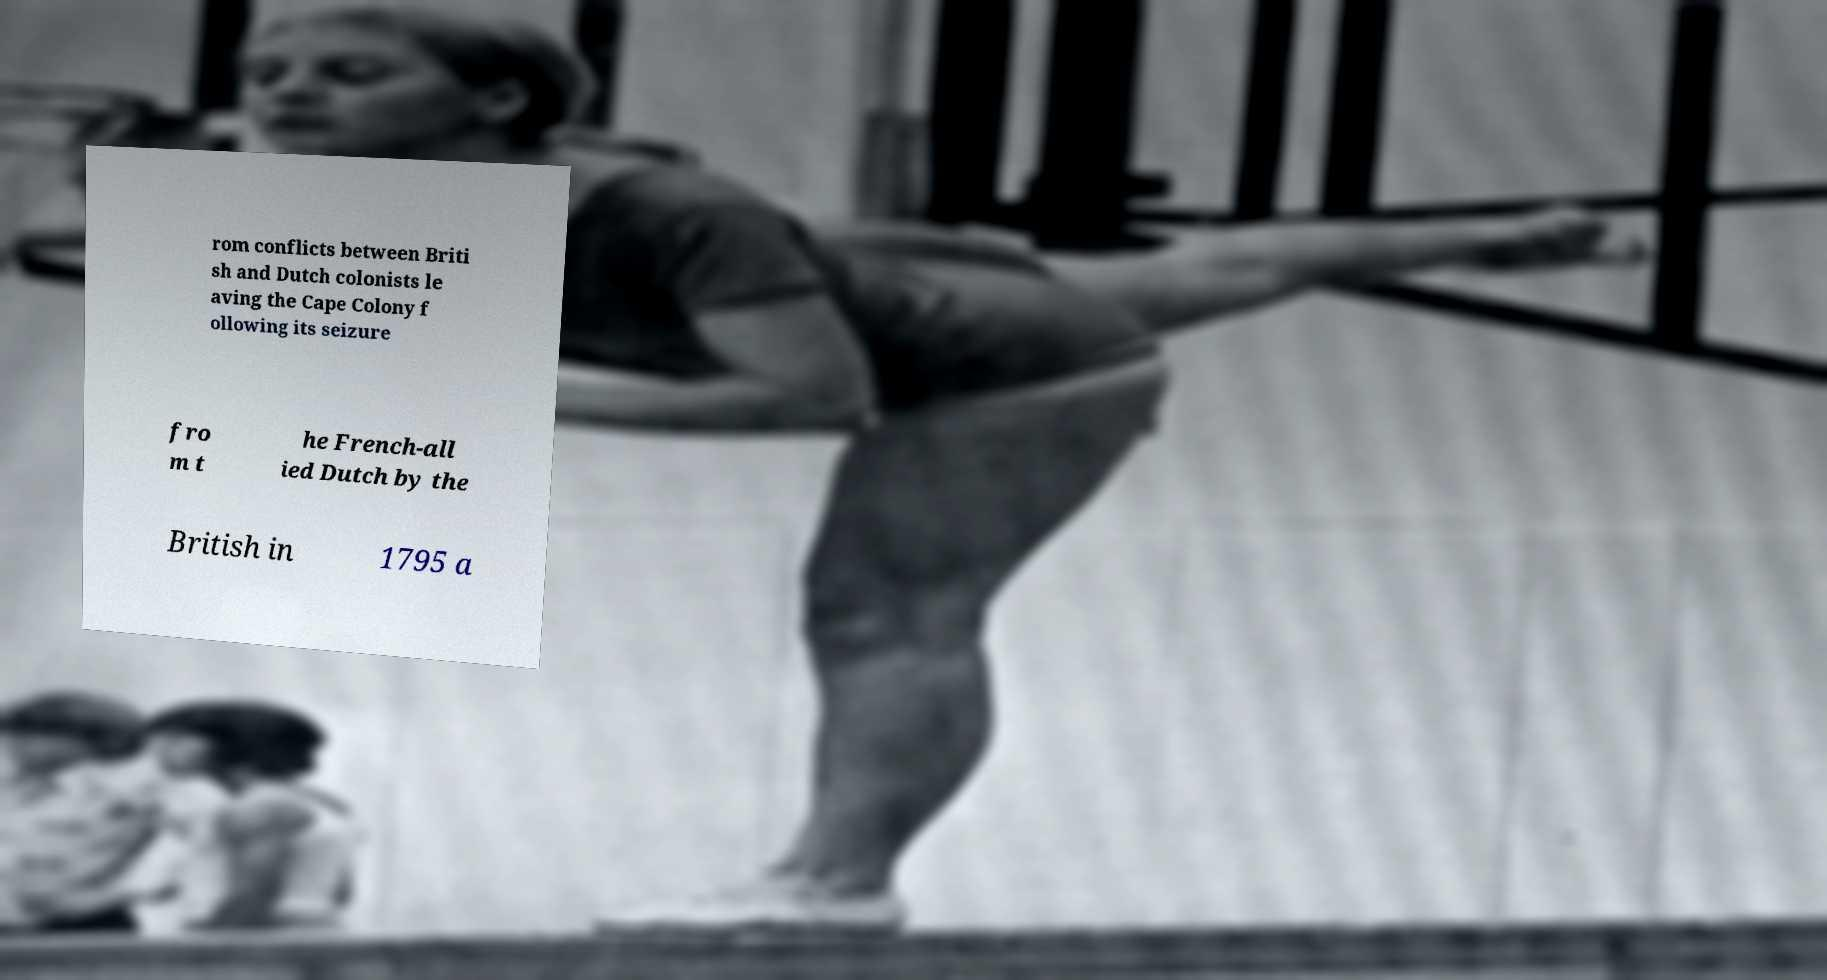Can you read and provide the text displayed in the image?This photo seems to have some interesting text. Can you extract and type it out for me? rom conflicts between Briti sh and Dutch colonists le aving the Cape Colony f ollowing its seizure fro m t he French-all ied Dutch by the British in 1795 a 